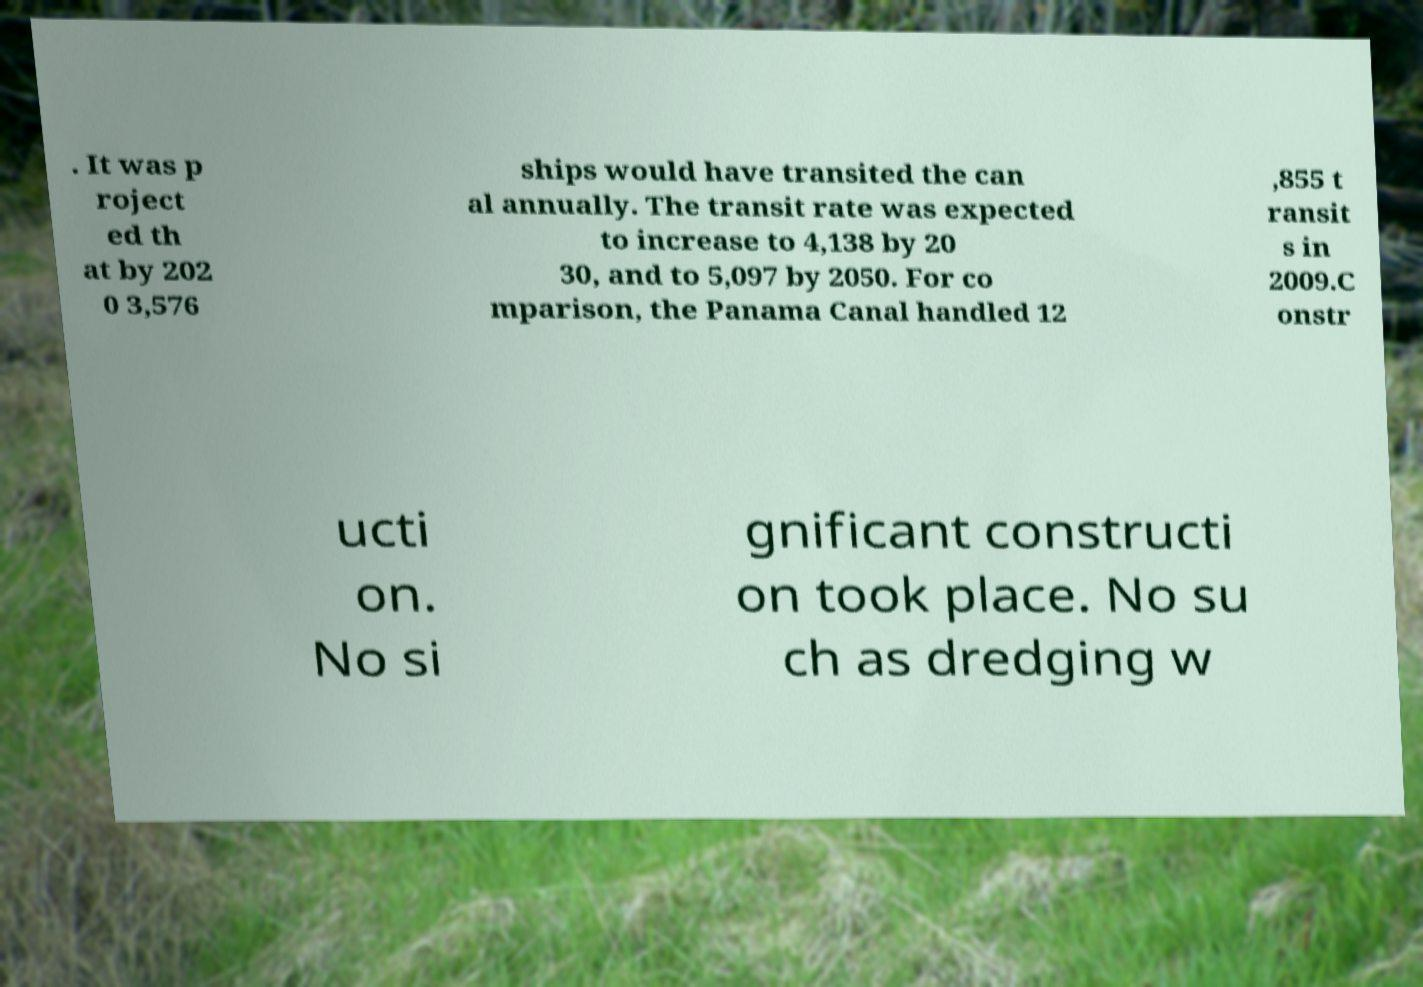I need the written content from this picture converted into text. Can you do that? . It was p roject ed th at by 202 0 3,576 ships would have transited the can al annually. The transit rate was expected to increase to 4,138 by 20 30, and to 5,097 by 2050. For co mparison, the Panama Canal handled 12 ,855 t ransit s in 2009.C onstr ucti on. No si gnificant constructi on took place. No su ch as dredging w 